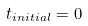<formula> <loc_0><loc_0><loc_500><loc_500>t _ { i n i t i a l } = 0</formula> 